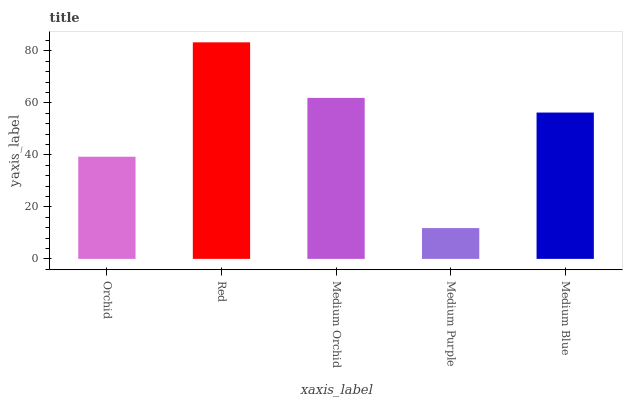Is Medium Orchid the minimum?
Answer yes or no. No. Is Medium Orchid the maximum?
Answer yes or no. No. Is Red greater than Medium Orchid?
Answer yes or no. Yes. Is Medium Orchid less than Red?
Answer yes or no. Yes. Is Medium Orchid greater than Red?
Answer yes or no. No. Is Red less than Medium Orchid?
Answer yes or no. No. Is Medium Blue the high median?
Answer yes or no. Yes. Is Medium Blue the low median?
Answer yes or no. Yes. Is Medium Orchid the high median?
Answer yes or no. No. Is Orchid the low median?
Answer yes or no. No. 